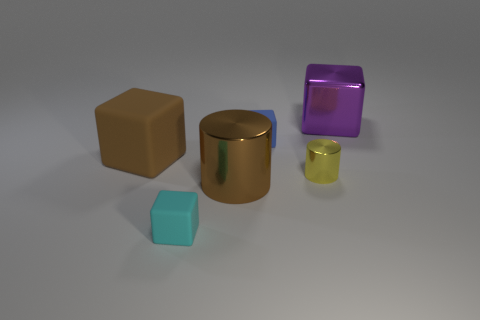How many other objects are there of the same size as the blue block?
Ensure brevity in your answer.  2. What material is the tiny thing to the right of the small blue matte thing?
Offer a very short reply. Metal. What shape is the object that is in front of the big metal thing that is to the left of the big shiny object that is behind the large matte object?
Offer a very short reply. Cube. Do the blue object and the yellow cylinder have the same size?
Make the answer very short. Yes. What number of objects are either large red metallic cylinders or small blocks in front of the big rubber block?
Your answer should be very brief. 1. What number of objects are large brown things in front of the yellow metallic cylinder or things behind the cyan cube?
Provide a succinct answer. 5. Are there any large metal things in front of the big purple block?
Provide a succinct answer. Yes. There is a rubber cube in front of the big metal thing in front of the big metal object right of the brown metal object; what is its color?
Make the answer very short. Cyan. Is the purple thing the same shape as the large brown metal thing?
Keep it short and to the point. No. What color is the other small thing that is made of the same material as the purple object?
Your response must be concise. Yellow. 